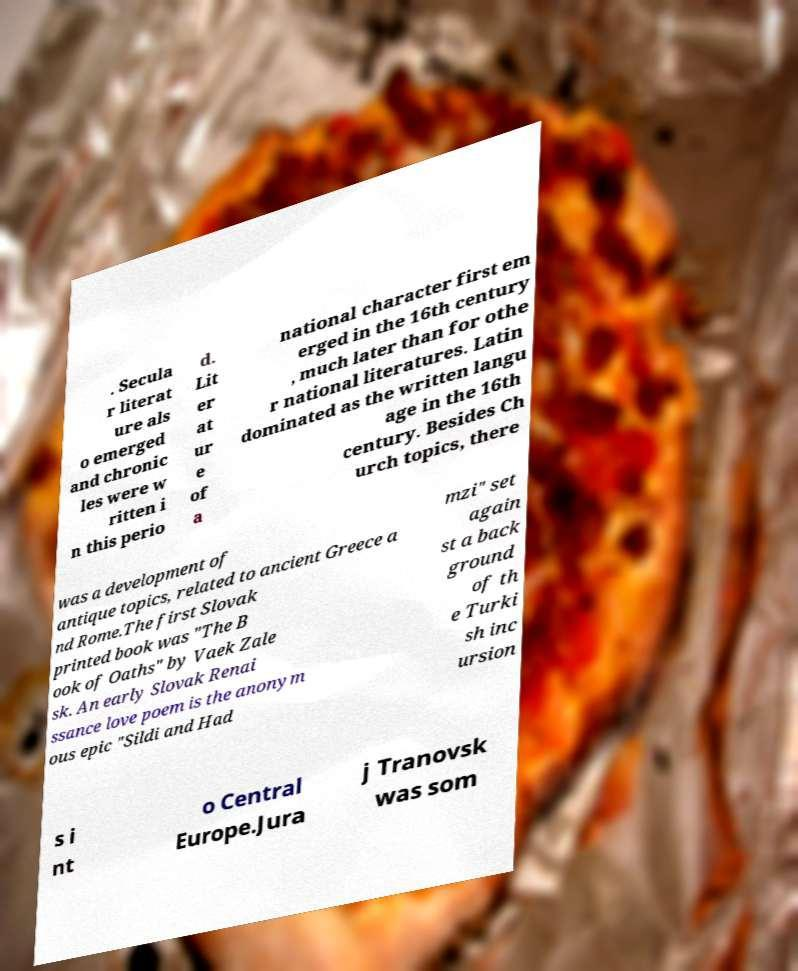Please identify and transcribe the text found in this image. . Secula r literat ure als o emerged and chronic les were w ritten i n this perio d. Lit er at ur e of a national character first em erged in the 16th century , much later than for othe r national literatures. Latin dominated as the written langu age in the 16th century. Besides Ch urch topics, there was a development of antique topics, related to ancient Greece a nd Rome.The first Slovak printed book was "The B ook of Oaths" by Vaek Zale sk. An early Slovak Renai ssance love poem is the anonym ous epic "Sildi and Had mzi" set again st a back ground of th e Turki sh inc ursion s i nt o Central Europe.Jura j Tranovsk was som 